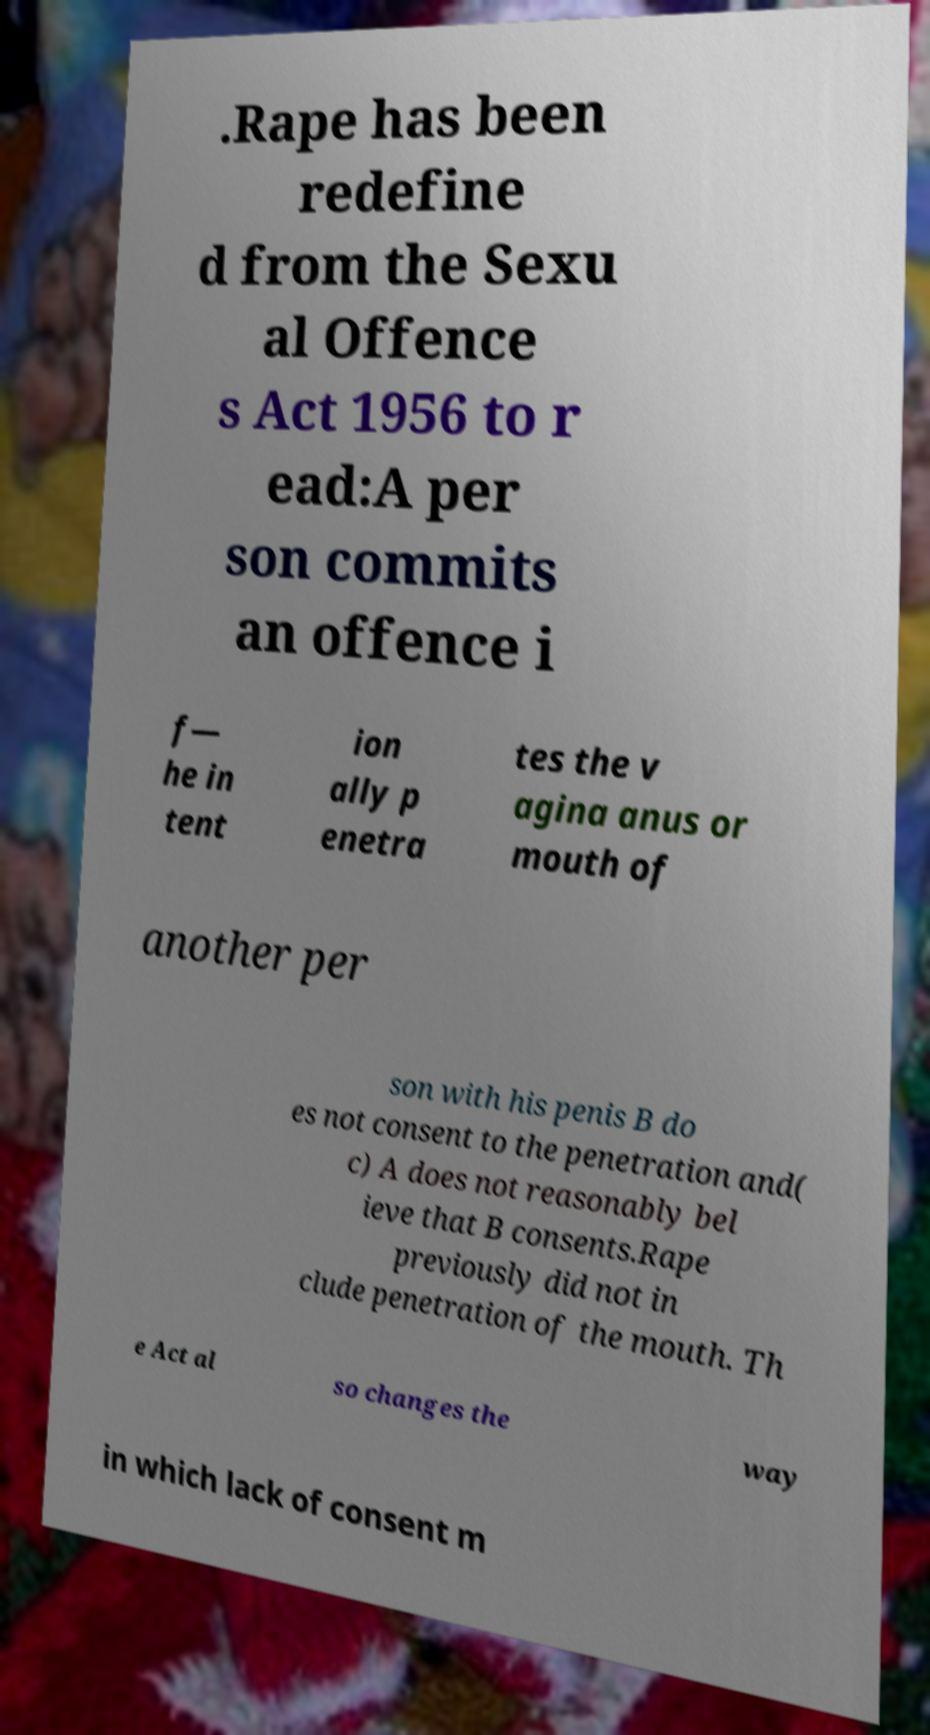I need the written content from this picture converted into text. Can you do that? .Rape has been redefine d from the Sexu al Offence s Act 1956 to r ead:A per son commits an offence i f— he in tent ion ally p enetra tes the v agina anus or mouth of another per son with his penis B do es not consent to the penetration and( c) A does not reasonably bel ieve that B consents.Rape previously did not in clude penetration of the mouth. Th e Act al so changes the way in which lack of consent m 